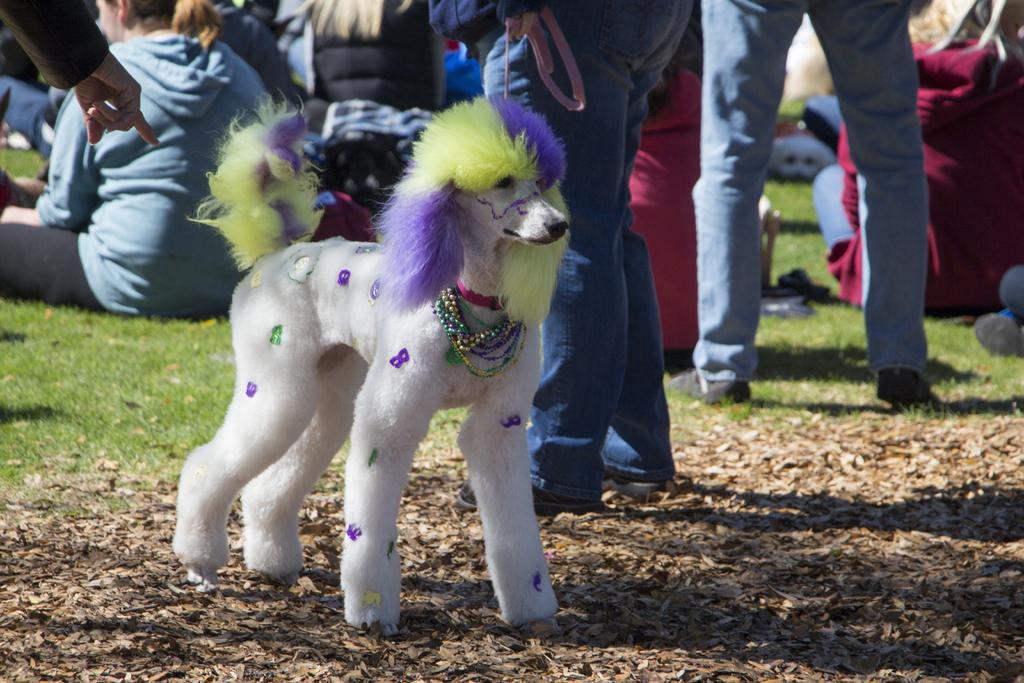How many people are in the image? There are a few people in the image. What type of animal is present in the image? There is a dog in the image. What is the ground covered with? The ground is covered with grass and dried leaves. What can be found on the ground in the image? There are objects on the ground. How many sisters are in the image? There is no mention of sisters in the image, so we cannot determine the number of sisters present. 